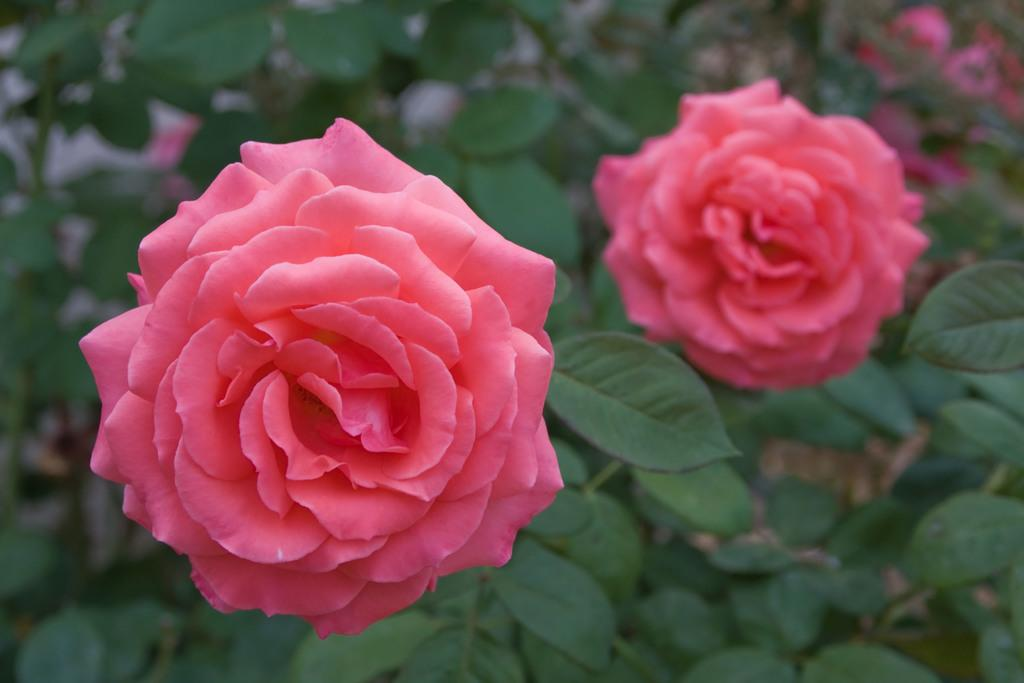What type of plants can be seen in the image? There are flowers and leaves in the image. What can be observed about the background of the image? The background of the image is blurred. What type of magic is being performed with the flowers in the image? There is no magic or any indication of a magical performance in the image; it simply features flowers and leaves. 